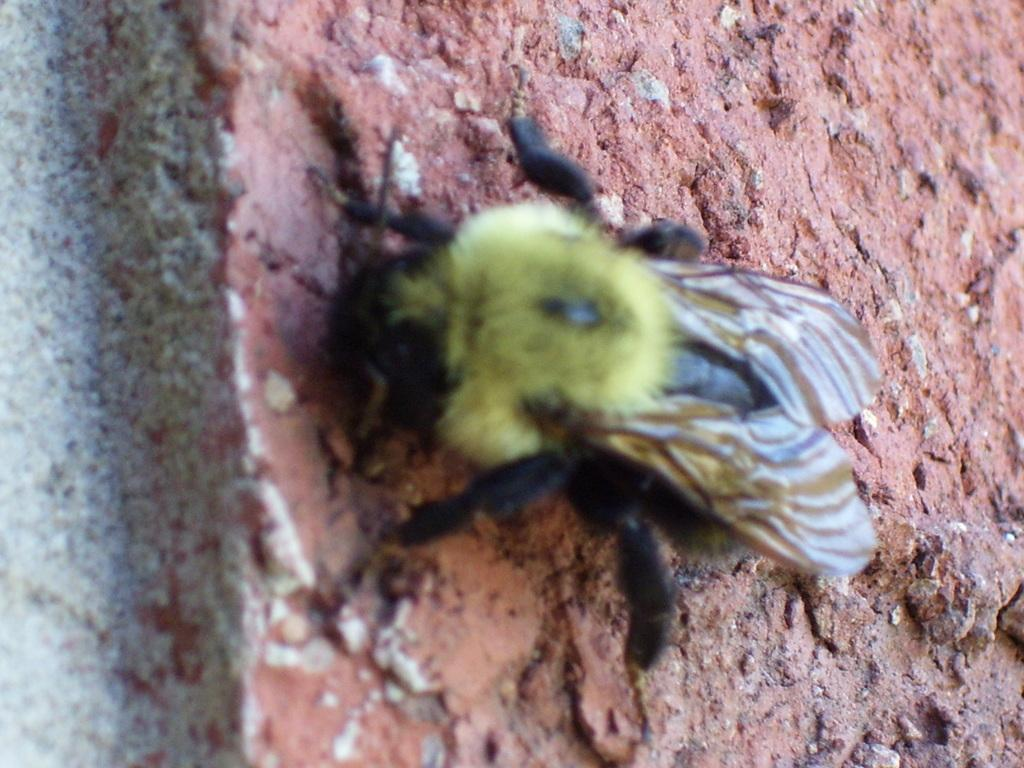What type of creature can be seen in the image? There is an insect in the image. Where is the insect located? The insect is on the ground. What else can be seen on the ground in the image? There are stones visible on the ground in the image. What type of rifle is the insect holding in the image? There is no rifle present in the image; it only features an insect and stones on the ground. 